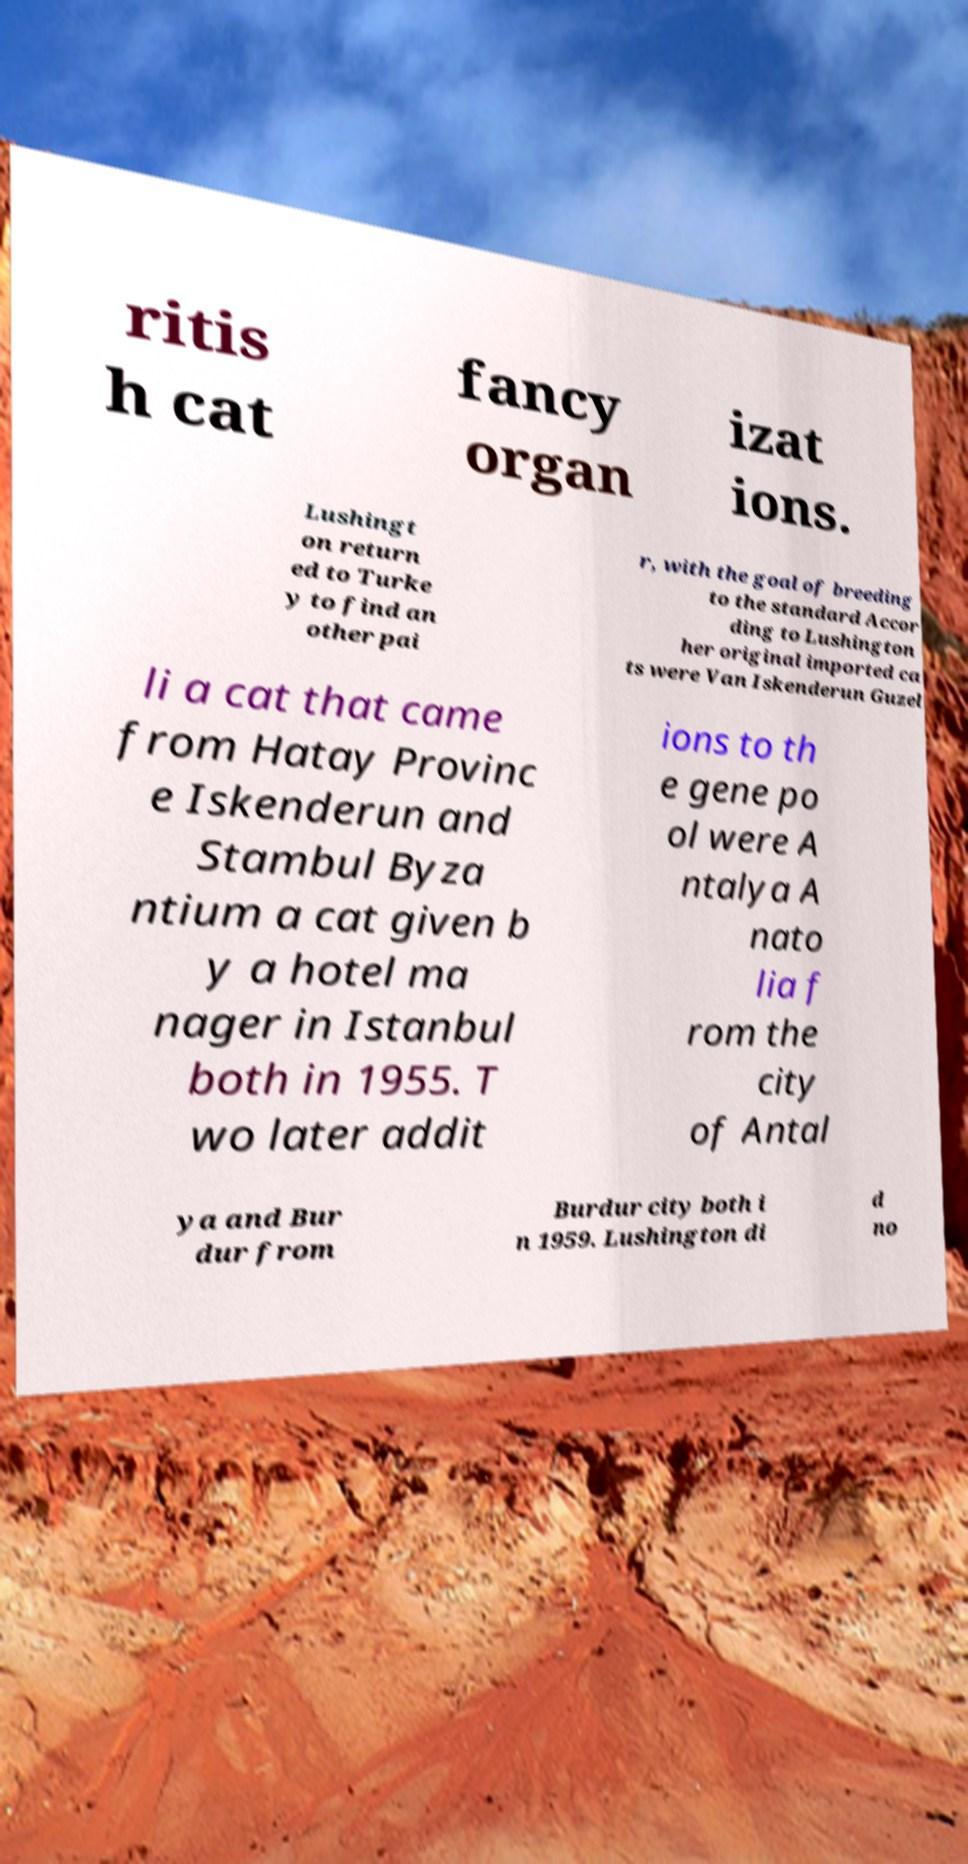I need the written content from this picture converted into text. Can you do that? ritis h cat fancy organ izat ions. Lushingt on return ed to Turke y to find an other pai r, with the goal of breeding to the standard Accor ding to Lushington her original imported ca ts were Van Iskenderun Guzel li a cat that came from Hatay Provinc e Iskenderun and Stambul Byza ntium a cat given b y a hotel ma nager in Istanbul both in 1955. T wo later addit ions to th e gene po ol were A ntalya A nato lia f rom the city of Antal ya and Bur dur from Burdur city both i n 1959. Lushington di d no 